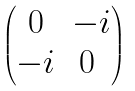Convert formula to latex. <formula><loc_0><loc_0><loc_500><loc_500>\begin{pmatrix} 0 & - i \\ - i & 0 \ \end{pmatrix}</formula> 